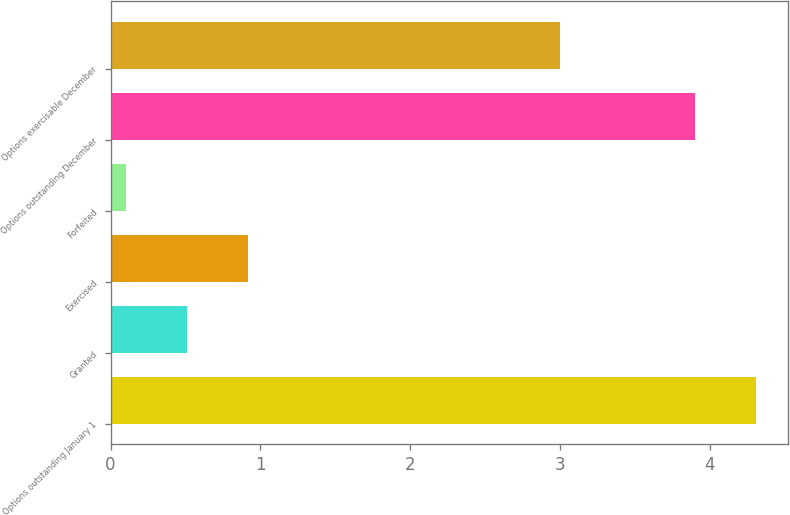<chart> <loc_0><loc_0><loc_500><loc_500><bar_chart><fcel>Options outstanding January 1<fcel>Granted<fcel>Exercised<fcel>Forfeited<fcel>Options outstanding December<fcel>Options exercisable December<nl><fcel>4.31<fcel>0.51<fcel>0.92<fcel>0.1<fcel>3.9<fcel>3<nl></chart> 